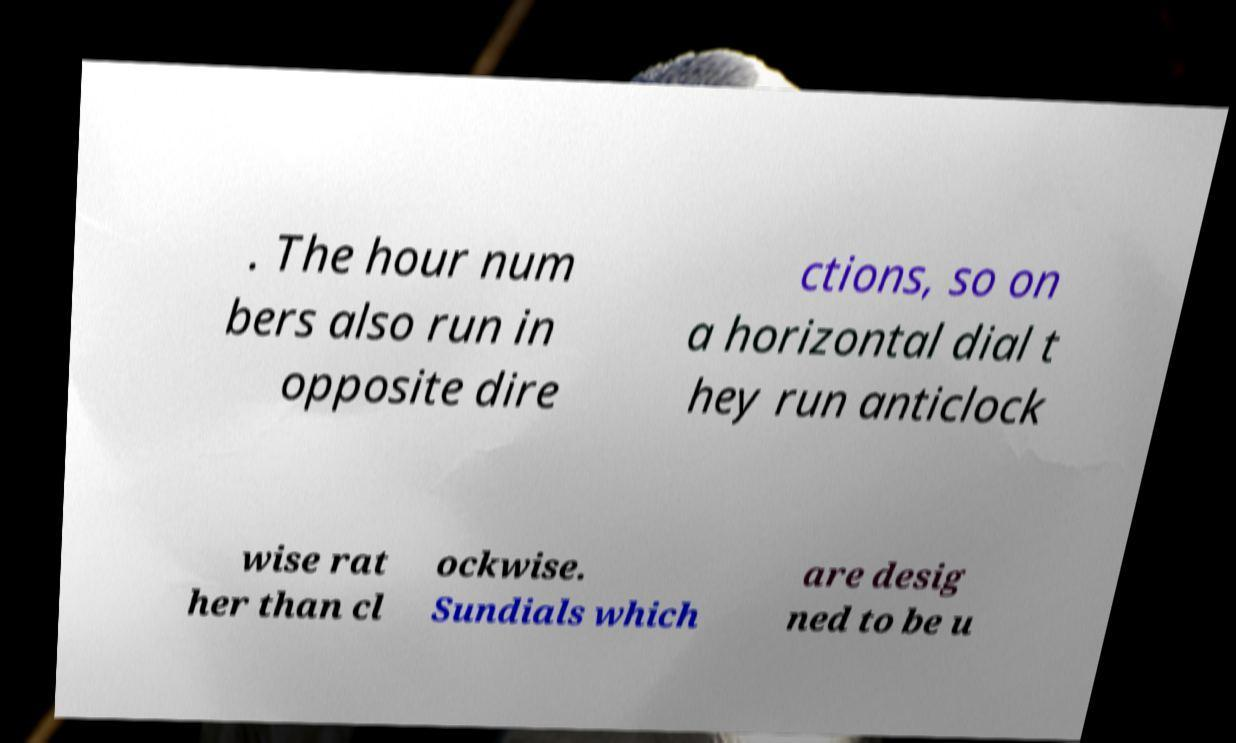Can you accurately transcribe the text from the provided image for me? . The hour num bers also run in opposite dire ctions, so on a horizontal dial t hey run anticlock wise rat her than cl ockwise. Sundials which are desig ned to be u 